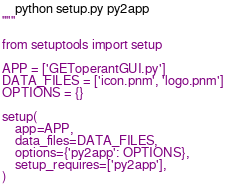Convert code to text. <code><loc_0><loc_0><loc_500><loc_500><_Python_>    python setup.py py2app
"""

from setuptools import setup

APP = ['GEToperantGUI.py']
DATA_FILES = ['icon.pnm', 'logo.pnm']
OPTIONS = {}

setup(
    app=APP,
    data_files=DATA_FILES,
    options={'py2app': OPTIONS},
    setup_requires=['py2app'],
)
</code> 